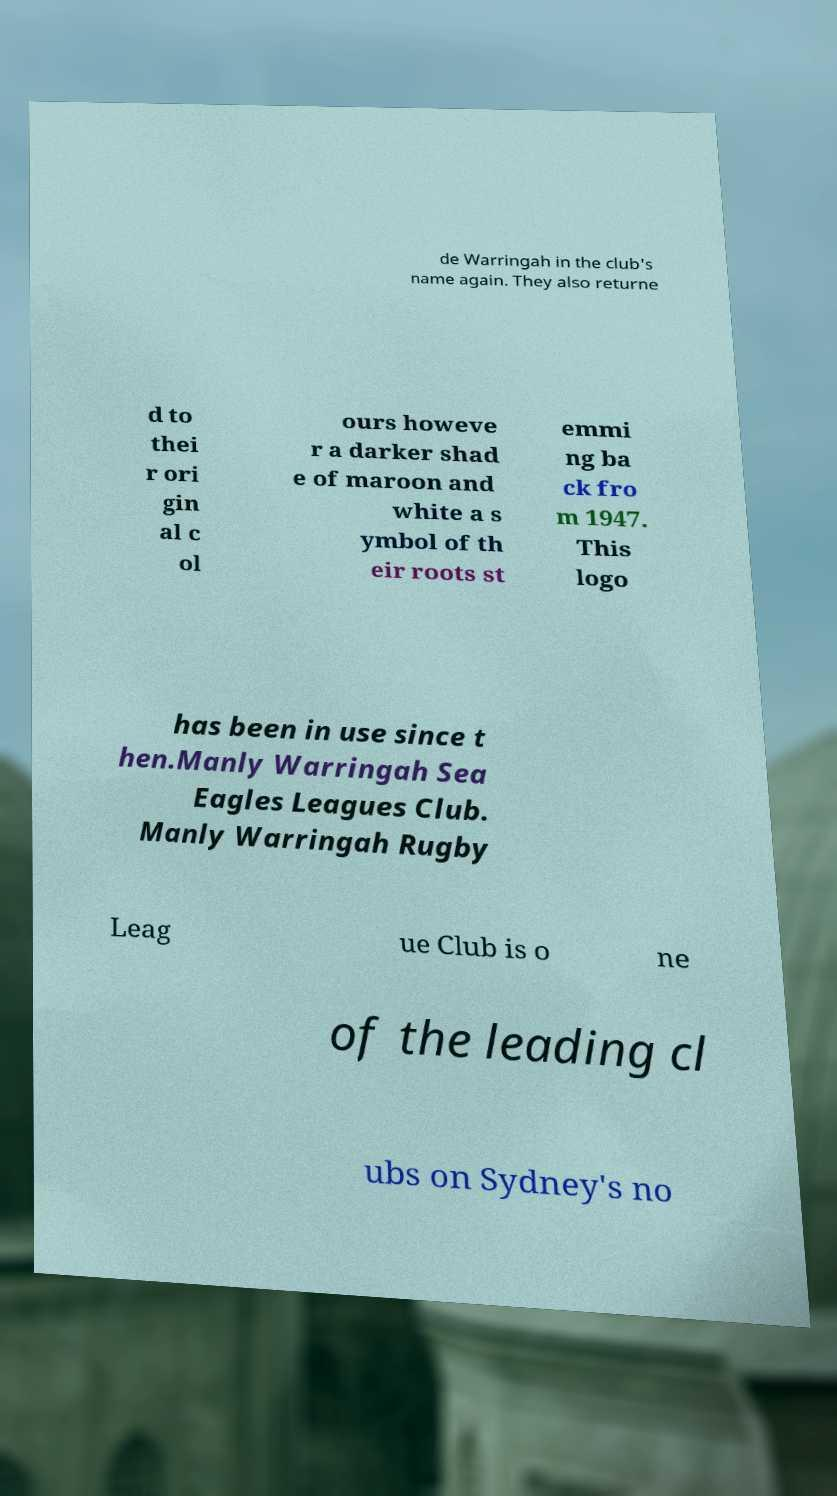Please identify and transcribe the text found in this image. de Warringah in the club's name again. They also returne d to thei r ori gin al c ol ours howeve r a darker shad e of maroon and white a s ymbol of th eir roots st emmi ng ba ck fro m 1947. This logo has been in use since t hen.Manly Warringah Sea Eagles Leagues Club. Manly Warringah Rugby Leag ue Club is o ne of the leading cl ubs on Sydney's no 